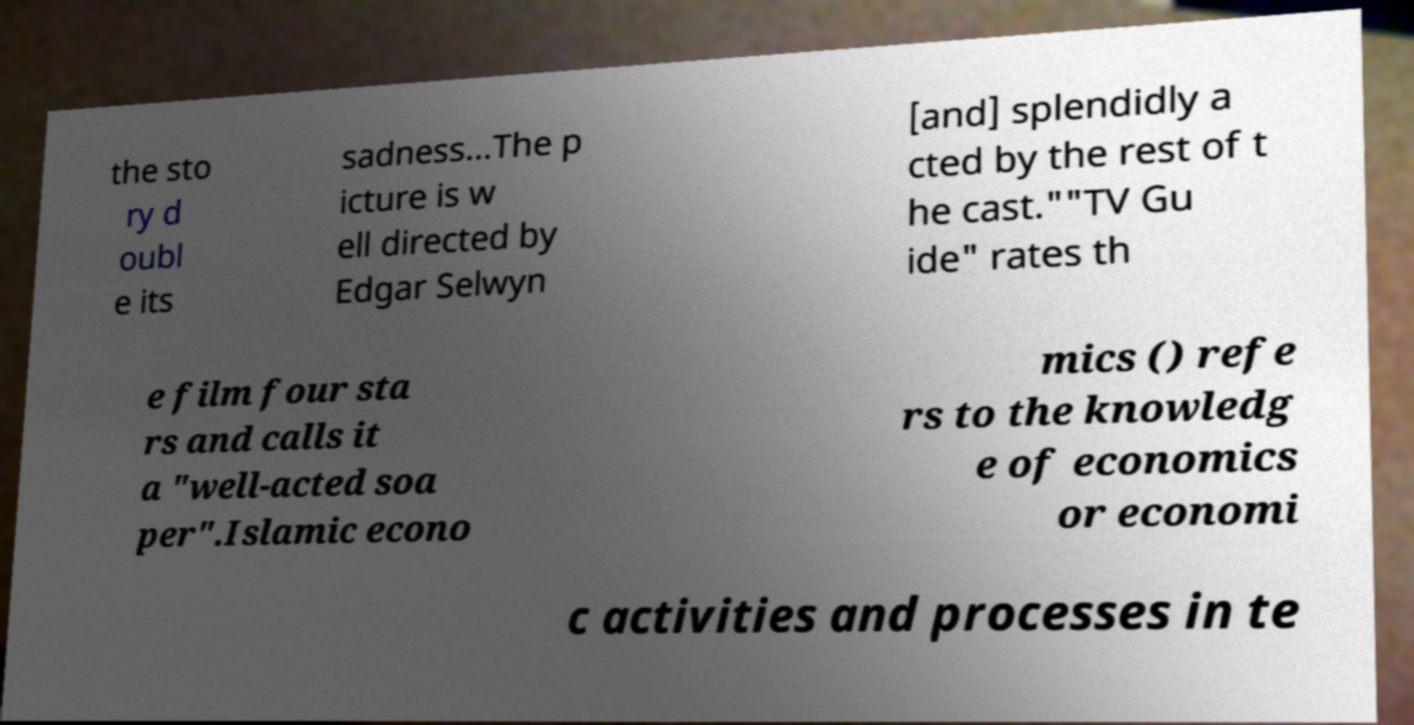Can you read and provide the text displayed in the image?This photo seems to have some interesting text. Can you extract and type it out for me? the sto ry d oubl e its sadness...The p icture is w ell directed by Edgar Selwyn [and] splendidly a cted by the rest of t he cast.""TV Gu ide" rates th e film four sta rs and calls it a "well-acted soa per".Islamic econo mics () refe rs to the knowledg e of economics or economi c activities and processes in te 